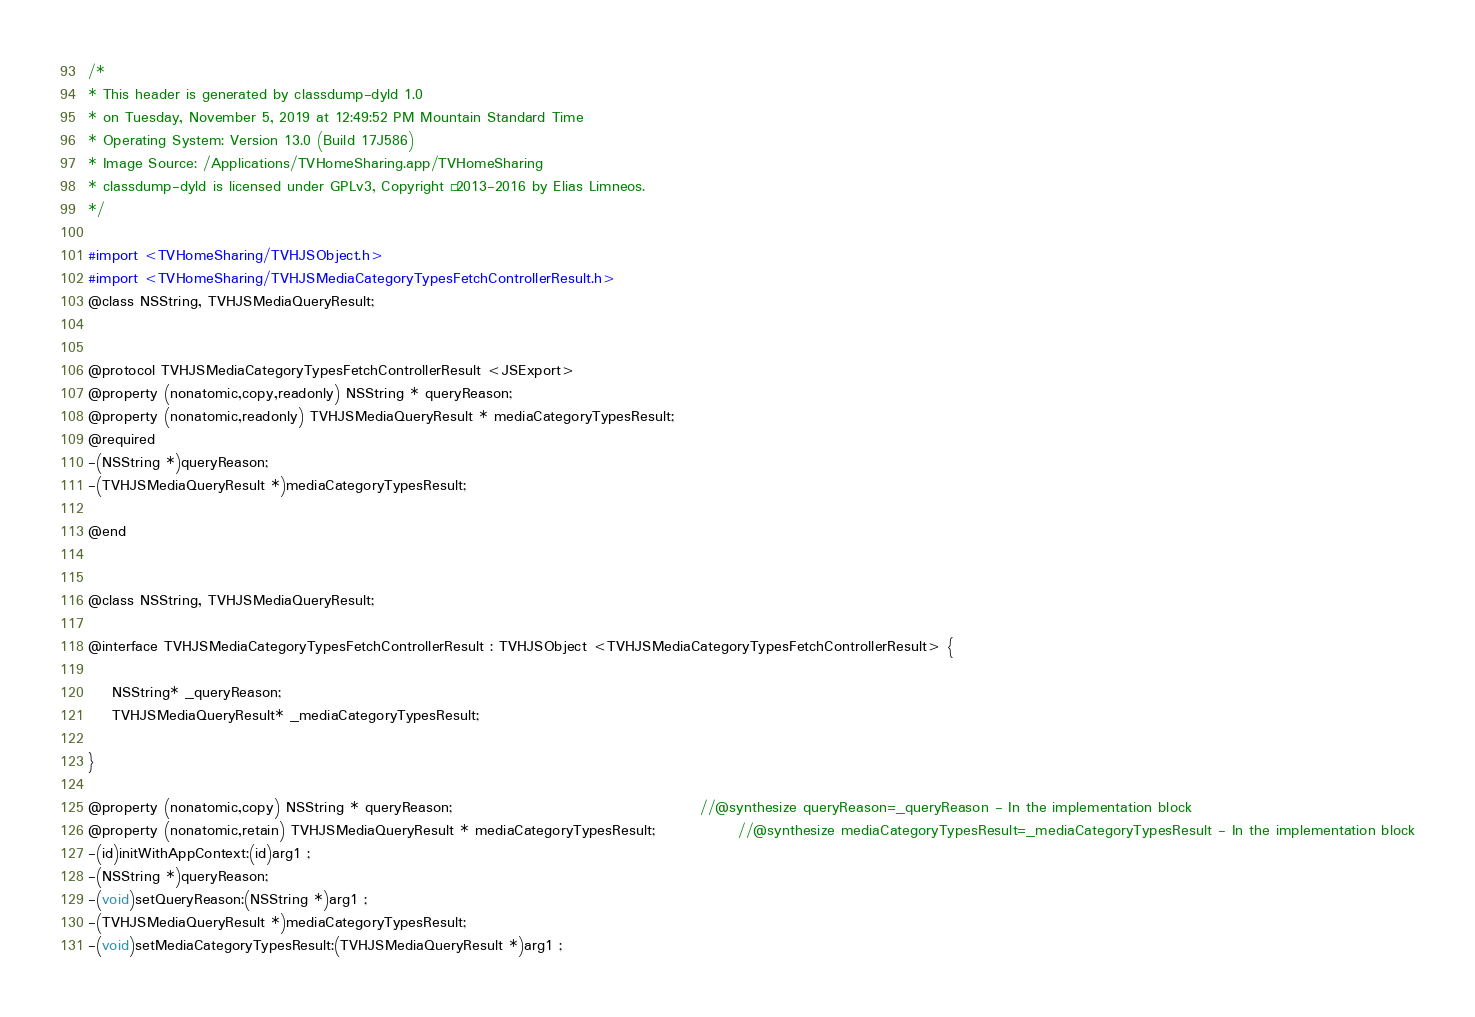<code> <loc_0><loc_0><loc_500><loc_500><_C_>/*
* This header is generated by classdump-dyld 1.0
* on Tuesday, November 5, 2019 at 12:49:52 PM Mountain Standard Time
* Operating System: Version 13.0 (Build 17J586)
* Image Source: /Applications/TVHomeSharing.app/TVHomeSharing
* classdump-dyld is licensed under GPLv3, Copyright © 2013-2016 by Elias Limneos.
*/

#import <TVHomeSharing/TVHJSObject.h>
#import <TVHomeSharing/TVHJSMediaCategoryTypesFetchControllerResult.h>
@class NSString, TVHJSMediaQueryResult;


@protocol TVHJSMediaCategoryTypesFetchControllerResult <JSExport>
@property (nonatomic,copy,readonly) NSString * queryReason; 
@property (nonatomic,readonly) TVHJSMediaQueryResult * mediaCategoryTypesResult; 
@required
-(NSString *)queryReason;
-(TVHJSMediaQueryResult *)mediaCategoryTypesResult;

@end


@class NSString, TVHJSMediaQueryResult;

@interface TVHJSMediaCategoryTypesFetchControllerResult : TVHJSObject <TVHJSMediaCategoryTypesFetchControllerResult> {

	NSString* _queryReason;
	TVHJSMediaQueryResult* _mediaCategoryTypesResult;

}

@property (nonatomic,copy) NSString * queryReason;                                          //@synthesize queryReason=_queryReason - In the implementation block
@property (nonatomic,retain) TVHJSMediaQueryResult * mediaCategoryTypesResult;              //@synthesize mediaCategoryTypesResult=_mediaCategoryTypesResult - In the implementation block
-(id)initWithAppContext:(id)arg1 ;
-(NSString *)queryReason;
-(void)setQueryReason:(NSString *)arg1 ;
-(TVHJSMediaQueryResult *)mediaCategoryTypesResult;
-(void)setMediaCategoryTypesResult:(TVHJSMediaQueryResult *)arg1 ;</code> 